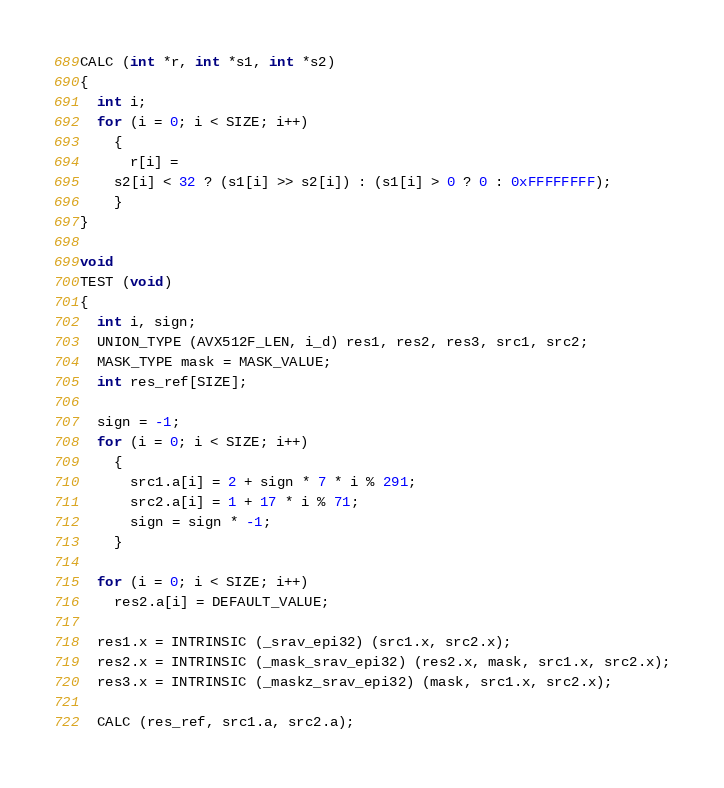<code> <loc_0><loc_0><loc_500><loc_500><_C_>CALC (int *r, int *s1, int *s2)
{
  int i;
  for (i = 0; i < SIZE; i++)
    {
      r[i] =
	s2[i] < 32 ? (s1[i] >> s2[i]) : (s1[i] > 0 ? 0 : 0xFFFFFFFF);
    }
}

void
TEST (void)
{
  int i, sign;
  UNION_TYPE (AVX512F_LEN, i_d) res1, res2, res3, src1, src2;
  MASK_TYPE mask = MASK_VALUE;
  int res_ref[SIZE];

  sign = -1;
  for (i = 0; i < SIZE; i++)
    {
      src1.a[i] = 2 + sign * 7 * i % 291;
      src2.a[i] = 1 + 17 * i % 71;
      sign = sign * -1;
    }

  for (i = 0; i < SIZE; i++)
    res2.a[i] = DEFAULT_VALUE;

  res1.x = INTRINSIC (_srav_epi32) (src1.x, src2.x);
  res2.x = INTRINSIC (_mask_srav_epi32) (res2.x, mask, src1.x, src2.x);
  res3.x = INTRINSIC (_maskz_srav_epi32) (mask, src1.x, src2.x);

  CALC (res_ref, src1.a, src2.a);
</code> 